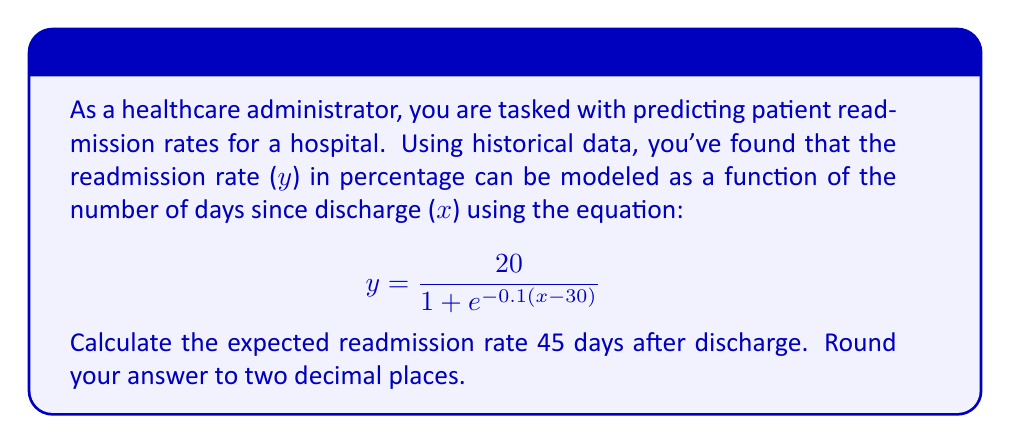Solve this math problem. To solve this problem, we'll follow these steps:

1. Identify the given equation:
   $$ y = \frac{20}{1 + e^{-0.1(x-30)}} $$

2. Substitute x = 45 (days since discharge) into the equation:
   $$ y = \frac{20}{1 + e^{-0.1(45-30)}} $$

3. Simplify the expression inside the exponential:
   $$ y = \frac{20}{1 + e^{-0.1(15)}} $$

4. Calculate the value of the exponential term:
   $e^{-0.1(15)} = e^{-1.5} \approx 0.2231$

5. Substitute this value back into the equation:
   $$ y = \frac{20}{1 + 0.2231} $$

6. Perform the division:
   $$ y = \frac{20}{1.2231} \approx 16.3519 $$

7. Round the result to two decimal places:
   $y \approx 16.35$

Therefore, the expected readmission rate 45 days after discharge is approximately 16.35%.
Answer: 16.35% 